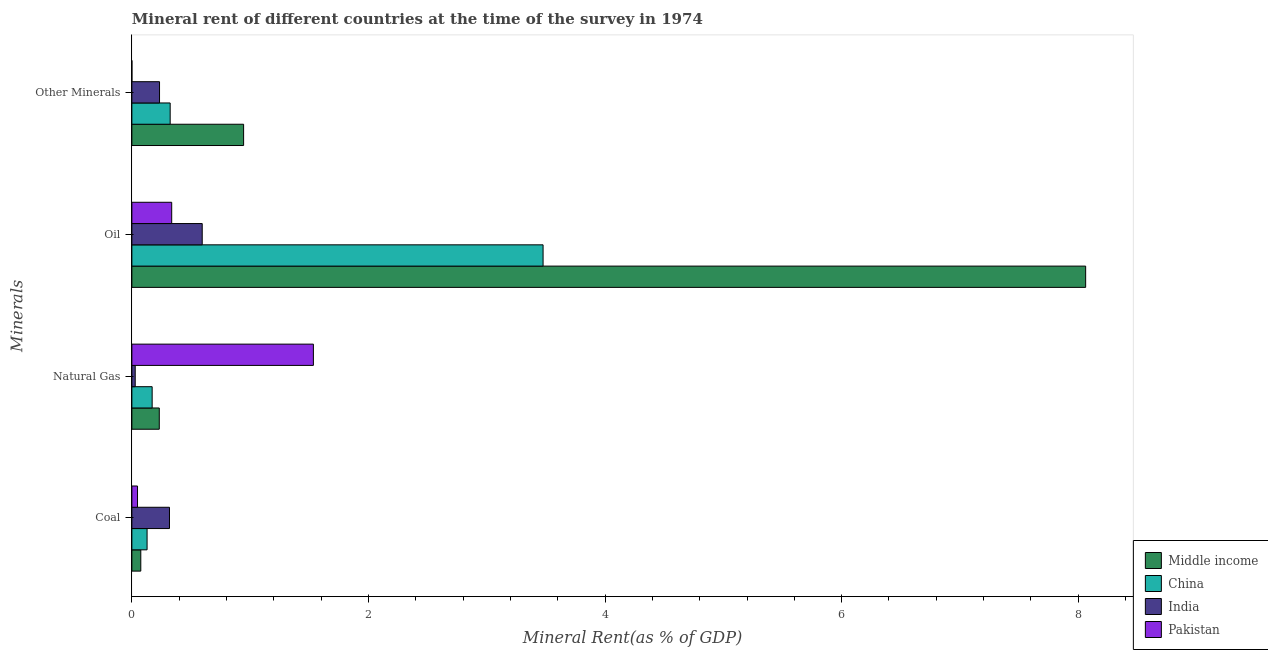How many groups of bars are there?
Your answer should be compact. 4. Are the number of bars per tick equal to the number of legend labels?
Your answer should be compact. Yes. How many bars are there on the 1st tick from the top?
Make the answer very short. 4. What is the label of the 1st group of bars from the top?
Give a very brief answer. Other Minerals. What is the coal rent in China?
Ensure brevity in your answer.  0.13. Across all countries, what is the maximum natural gas rent?
Make the answer very short. 1.53. Across all countries, what is the minimum coal rent?
Your answer should be compact. 0.05. What is the total natural gas rent in the graph?
Provide a short and direct response. 1.97. What is the difference between the oil rent in Pakistan and that in Middle income?
Keep it short and to the point. -7.73. What is the difference between the  rent of other minerals in India and the natural gas rent in China?
Make the answer very short. 0.06. What is the average coal rent per country?
Offer a very short reply. 0.14. What is the difference between the  rent of other minerals and natural gas rent in China?
Your answer should be very brief. 0.15. What is the ratio of the oil rent in Pakistan to that in India?
Offer a very short reply. 0.57. Is the difference between the  rent of other minerals in India and Middle income greater than the difference between the oil rent in India and Middle income?
Give a very brief answer. Yes. What is the difference between the highest and the second highest oil rent?
Offer a very short reply. 4.59. What is the difference between the highest and the lowest oil rent?
Your response must be concise. 7.73. Is it the case that in every country, the sum of the  rent of other minerals and oil rent is greater than the sum of natural gas rent and coal rent?
Your answer should be very brief. No. What does the 4th bar from the top in Oil represents?
Your response must be concise. Middle income. What does the 1st bar from the bottom in Natural Gas represents?
Ensure brevity in your answer.  Middle income. How many bars are there?
Provide a succinct answer. 16. How many countries are there in the graph?
Your answer should be very brief. 4. Does the graph contain grids?
Your answer should be compact. No. How many legend labels are there?
Your answer should be compact. 4. What is the title of the graph?
Keep it short and to the point. Mineral rent of different countries at the time of the survey in 1974. What is the label or title of the X-axis?
Your response must be concise. Mineral Rent(as % of GDP). What is the label or title of the Y-axis?
Provide a succinct answer. Minerals. What is the Mineral Rent(as % of GDP) of Middle income in Coal?
Your answer should be compact. 0.08. What is the Mineral Rent(as % of GDP) in China in Coal?
Keep it short and to the point. 0.13. What is the Mineral Rent(as % of GDP) of India in Coal?
Offer a terse response. 0.32. What is the Mineral Rent(as % of GDP) in Pakistan in Coal?
Ensure brevity in your answer.  0.05. What is the Mineral Rent(as % of GDP) in Middle income in Natural Gas?
Make the answer very short. 0.23. What is the Mineral Rent(as % of GDP) of China in Natural Gas?
Keep it short and to the point. 0.17. What is the Mineral Rent(as % of GDP) in India in Natural Gas?
Offer a terse response. 0.03. What is the Mineral Rent(as % of GDP) in Pakistan in Natural Gas?
Make the answer very short. 1.53. What is the Mineral Rent(as % of GDP) in Middle income in Oil?
Provide a short and direct response. 8.06. What is the Mineral Rent(as % of GDP) in China in Oil?
Make the answer very short. 3.48. What is the Mineral Rent(as % of GDP) in India in Oil?
Your response must be concise. 0.59. What is the Mineral Rent(as % of GDP) of Pakistan in Oil?
Your answer should be compact. 0.34. What is the Mineral Rent(as % of GDP) of Middle income in Other Minerals?
Give a very brief answer. 0.94. What is the Mineral Rent(as % of GDP) in China in Other Minerals?
Your answer should be very brief. 0.32. What is the Mineral Rent(as % of GDP) of India in Other Minerals?
Your answer should be compact. 0.23. What is the Mineral Rent(as % of GDP) in Pakistan in Other Minerals?
Offer a terse response. 8.55208765846003e-5. Across all Minerals, what is the maximum Mineral Rent(as % of GDP) of Middle income?
Your answer should be compact. 8.06. Across all Minerals, what is the maximum Mineral Rent(as % of GDP) of China?
Make the answer very short. 3.48. Across all Minerals, what is the maximum Mineral Rent(as % of GDP) in India?
Keep it short and to the point. 0.59. Across all Minerals, what is the maximum Mineral Rent(as % of GDP) of Pakistan?
Offer a very short reply. 1.53. Across all Minerals, what is the minimum Mineral Rent(as % of GDP) in Middle income?
Your answer should be compact. 0.08. Across all Minerals, what is the minimum Mineral Rent(as % of GDP) in China?
Keep it short and to the point. 0.13. Across all Minerals, what is the minimum Mineral Rent(as % of GDP) in India?
Provide a succinct answer. 0.03. Across all Minerals, what is the minimum Mineral Rent(as % of GDP) in Pakistan?
Your answer should be very brief. 8.55208765846003e-5. What is the total Mineral Rent(as % of GDP) of Middle income in the graph?
Your answer should be compact. 9.31. What is the total Mineral Rent(as % of GDP) in China in the graph?
Keep it short and to the point. 4.1. What is the total Mineral Rent(as % of GDP) in India in the graph?
Offer a terse response. 1.17. What is the total Mineral Rent(as % of GDP) of Pakistan in the graph?
Ensure brevity in your answer.  1.92. What is the difference between the Mineral Rent(as % of GDP) in Middle income in Coal and that in Natural Gas?
Keep it short and to the point. -0.16. What is the difference between the Mineral Rent(as % of GDP) of China in Coal and that in Natural Gas?
Keep it short and to the point. -0.04. What is the difference between the Mineral Rent(as % of GDP) in India in Coal and that in Natural Gas?
Your answer should be compact. 0.29. What is the difference between the Mineral Rent(as % of GDP) in Pakistan in Coal and that in Natural Gas?
Give a very brief answer. -1.49. What is the difference between the Mineral Rent(as % of GDP) of Middle income in Coal and that in Oil?
Offer a very short reply. -7.99. What is the difference between the Mineral Rent(as % of GDP) in China in Coal and that in Oil?
Give a very brief answer. -3.35. What is the difference between the Mineral Rent(as % of GDP) in India in Coal and that in Oil?
Offer a very short reply. -0.28. What is the difference between the Mineral Rent(as % of GDP) in Pakistan in Coal and that in Oil?
Provide a succinct answer. -0.29. What is the difference between the Mineral Rent(as % of GDP) in Middle income in Coal and that in Other Minerals?
Keep it short and to the point. -0.87. What is the difference between the Mineral Rent(as % of GDP) of China in Coal and that in Other Minerals?
Your answer should be compact. -0.2. What is the difference between the Mineral Rent(as % of GDP) of India in Coal and that in Other Minerals?
Keep it short and to the point. 0.08. What is the difference between the Mineral Rent(as % of GDP) in Pakistan in Coal and that in Other Minerals?
Your answer should be very brief. 0.05. What is the difference between the Mineral Rent(as % of GDP) of Middle income in Natural Gas and that in Oil?
Provide a succinct answer. -7.83. What is the difference between the Mineral Rent(as % of GDP) in China in Natural Gas and that in Oil?
Offer a very short reply. -3.3. What is the difference between the Mineral Rent(as % of GDP) in India in Natural Gas and that in Oil?
Offer a very short reply. -0.57. What is the difference between the Mineral Rent(as % of GDP) in Pakistan in Natural Gas and that in Oil?
Ensure brevity in your answer.  1.2. What is the difference between the Mineral Rent(as % of GDP) in Middle income in Natural Gas and that in Other Minerals?
Provide a succinct answer. -0.71. What is the difference between the Mineral Rent(as % of GDP) in China in Natural Gas and that in Other Minerals?
Make the answer very short. -0.15. What is the difference between the Mineral Rent(as % of GDP) in India in Natural Gas and that in Other Minerals?
Offer a very short reply. -0.21. What is the difference between the Mineral Rent(as % of GDP) of Pakistan in Natural Gas and that in Other Minerals?
Keep it short and to the point. 1.53. What is the difference between the Mineral Rent(as % of GDP) in Middle income in Oil and that in Other Minerals?
Your answer should be very brief. 7.12. What is the difference between the Mineral Rent(as % of GDP) of China in Oil and that in Other Minerals?
Offer a terse response. 3.15. What is the difference between the Mineral Rent(as % of GDP) in India in Oil and that in Other Minerals?
Keep it short and to the point. 0.36. What is the difference between the Mineral Rent(as % of GDP) of Pakistan in Oil and that in Other Minerals?
Provide a short and direct response. 0.34. What is the difference between the Mineral Rent(as % of GDP) of Middle income in Coal and the Mineral Rent(as % of GDP) of China in Natural Gas?
Your answer should be very brief. -0.1. What is the difference between the Mineral Rent(as % of GDP) of Middle income in Coal and the Mineral Rent(as % of GDP) of India in Natural Gas?
Give a very brief answer. 0.05. What is the difference between the Mineral Rent(as % of GDP) in Middle income in Coal and the Mineral Rent(as % of GDP) in Pakistan in Natural Gas?
Your answer should be very brief. -1.46. What is the difference between the Mineral Rent(as % of GDP) in China in Coal and the Mineral Rent(as % of GDP) in India in Natural Gas?
Provide a short and direct response. 0.1. What is the difference between the Mineral Rent(as % of GDP) of China in Coal and the Mineral Rent(as % of GDP) of Pakistan in Natural Gas?
Ensure brevity in your answer.  -1.41. What is the difference between the Mineral Rent(as % of GDP) of India in Coal and the Mineral Rent(as % of GDP) of Pakistan in Natural Gas?
Your response must be concise. -1.22. What is the difference between the Mineral Rent(as % of GDP) of Middle income in Coal and the Mineral Rent(as % of GDP) of China in Oil?
Offer a very short reply. -3.4. What is the difference between the Mineral Rent(as % of GDP) of Middle income in Coal and the Mineral Rent(as % of GDP) of India in Oil?
Make the answer very short. -0.52. What is the difference between the Mineral Rent(as % of GDP) in Middle income in Coal and the Mineral Rent(as % of GDP) in Pakistan in Oil?
Offer a terse response. -0.26. What is the difference between the Mineral Rent(as % of GDP) of China in Coal and the Mineral Rent(as % of GDP) of India in Oil?
Provide a succinct answer. -0.47. What is the difference between the Mineral Rent(as % of GDP) in China in Coal and the Mineral Rent(as % of GDP) in Pakistan in Oil?
Provide a succinct answer. -0.21. What is the difference between the Mineral Rent(as % of GDP) of India in Coal and the Mineral Rent(as % of GDP) of Pakistan in Oil?
Keep it short and to the point. -0.02. What is the difference between the Mineral Rent(as % of GDP) in Middle income in Coal and the Mineral Rent(as % of GDP) in China in Other Minerals?
Keep it short and to the point. -0.25. What is the difference between the Mineral Rent(as % of GDP) of Middle income in Coal and the Mineral Rent(as % of GDP) of India in Other Minerals?
Keep it short and to the point. -0.16. What is the difference between the Mineral Rent(as % of GDP) in Middle income in Coal and the Mineral Rent(as % of GDP) in Pakistan in Other Minerals?
Your answer should be very brief. 0.08. What is the difference between the Mineral Rent(as % of GDP) in China in Coal and the Mineral Rent(as % of GDP) in India in Other Minerals?
Ensure brevity in your answer.  -0.11. What is the difference between the Mineral Rent(as % of GDP) in China in Coal and the Mineral Rent(as % of GDP) in Pakistan in Other Minerals?
Offer a terse response. 0.13. What is the difference between the Mineral Rent(as % of GDP) of India in Coal and the Mineral Rent(as % of GDP) of Pakistan in Other Minerals?
Provide a succinct answer. 0.32. What is the difference between the Mineral Rent(as % of GDP) in Middle income in Natural Gas and the Mineral Rent(as % of GDP) in China in Oil?
Provide a succinct answer. -3.24. What is the difference between the Mineral Rent(as % of GDP) in Middle income in Natural Gas and the Mineral Rent(as % of GDP) in India in Oil?
Make the answer very short. -0.36. What is the difference between the Mineral Rent(as % of GDP) of Middle income in Natural Gas and the Mineral Rent(as % of GDP) of Pakistan in Oil?
Make the answer very short. -0.1. What is the difference between the Mineral Rent(as % of GDP) in China in Natural Gas and the Mineral Rent(as % of GDP) in India in Oil?
Your response must be concise. -0.42. What is the difference between the Mineral Rent(as % of GDP) of China in Natural Gas and the Mineral Rent(as % of GDP) of Pakistan in Oil?
Your response must be concise. -0.17. What is the difference between the Mineral Rent(as % of GDP) of India in Natural Gas and the Mineral Rent(as % of GDP) of Pakistan in Oil?
Ensure brevity in your answer.  -0.31. What is the difference between the Mineral Rent(as % of GDP) of Middle income in Natural Gas and the Mineral Rent(as % of GDP) of China in Other Minerals?
Make the answer very short. -0.09. What is the difference between the Mineral Rent(as % of GDP) of Middle income in Natural Gas and the Mineral Rent(as % of GDP) of India in Other Minerals?
Give a very brief answer. -0. What is the difference between the Mineral Rent(as % of GDP) in Middle income in Natural Gas and the Mineral Rent(as % of GDP) in Pakistan in Other Minerals?
Provide a short and direct response. 0.23. What is the difference between the Mineral Rent(as % of GDP) of China in Natural Gas and the Mineral Rent(as % of GDP) of India in Other Minerals?
Make the answer very short. -0.06. What is the difference between the Mineral Rent(as % of GDP) of China in Natural Gas and the Mineral Rent(as % of GDP) of Pakistan in Other Minerals?
Keep it short and to the point. 0.17. What is the difference between the Mineral Rent(as % of GDP) in India in Natural Gas and the Mineral Rent(as % of GDP) in Pakistan in Other Minerals?
Offer a very short reply. 0.03. What is the difference between the Mineral Rent(as % of GDP) in Middle income in Oil and the Mineral Rent(as % of GDP) in China in Other Minerals?
Make the answer very short. 7.74. What is the difference between the Mineral Rent(as % of GDP) of Middle income in Oil and the Mineral Rent(as % of GDP) of India in Other Minerals?
Your response must be concise. 7.83. What is the difference between the Mineral Rent(as % of GDP) of Middle income in Oil and the Mineral Rent(as % of GDP) of Pakistan in Other Minerals?
Your answer should be very brief. 8.06. What is the difference between the Mineral Rent(as % of GDP) in China in Oil and the Mineral Rent(as % of GDP) in India in Other Minerals?
Make the answer very short. 3.24. What is the difference between the Mineral Rent(as % of GDP) in China in Oil and the Mineral Rent(as % of GDP) in Pakistan in Other Minerals?
Give a very brief answer. 3.48. What is the difference between the Mineral Rent(as % of GDP) in India in Oil and the Mineral Rent(as % of GDP) in Pakistan in Other Minerals?
Keep it short and to the point. 0.59. What is the average Mineral Rent(as % of GDP) in Middle income per Minerals?
Provide a succinct answer. 2.33. What is the average Mineral Rent(as % of GDP) in China per Minerals?
Provide a short and direct response. 1.02. What is the average Mineral Rent(as % of GDP) in India per Minerals?
Offer a very short reply. 0.29. What is the average Mineral Rent(as % of GDP) of Pakistan per Minerals?
Offer a very short reply. 0.48. What is the difference between the Mineral Rent(as % of GDP) of Middle income and Mineral Rent(as % of GDP) of China in Coal?
Keep it short and to the point. -0.05. What is the difference between the Mineral Rent(as % of GDP) in Middle income and Mineral Rent(as % of GDP) in India in Coal?
Ensure brevity in your answer.  -0.24. What is the difference between the Mineral Rent(as % of GDP) of Middle income and Mineral Rent(as % of GDP) of Pakistan in Coal?
Ensure brevity in your answer.  0.03. What is the difference between the Mineral Rent(as % of GDP) of China and Mineral Rent(as % of GDP) of India in Coal?
Provide a succinct answer. -0.19. What is the difference between the Mineral Rent(as % of GDP) in China and Mineral Rent(as % of GDP) in Pakistan in Coal?
Make the answer very short. 0.08. What is the difference between the Mineral Rent(as % of GDP) of India and Mineral Rent(as % of GDP) of Pakistan in Coal?
Your answer should be very brief. 0.27. What is the difference between the Mineral Rent(as % of GDP) in Middle income and Mineral Rent(as % of GDP) in China in Natural Gas?
Provide a short and direct response. 0.06. What is the difference between the Mineral Rent(as % of GDP) of Middle income and Mineral Rent(as % of GDP) of India in Natural Gas?
Offer a very short reply. 0.2. What is the difference between the Mineral Rent(as % of GDP) of Middle income and Mineral Rent(as % of GDP) of Pakistan in Natural Gas?
Offer a very short reply. -1.3. What is the difference between the Mineral Rent(as % of GDP) of China and Mineral Rent(as % of GDP) of India in Natural Gas?
Keep it short and to the point. 0.14. What is the difference between the Mineral Rent(as % of GDP) of China and Mineral Rent(as % of GDP) of Pakistan in Natural Gas?
Your answer should be very brief. -1.36. What is the difference between the Mineral Rent(as % of GDP) in India and Mineral Rent(as % of GDP) in Pakistan in Natural Gas?
Offer a very short reply. -1.51. What is the difference between the Mineral Rent(as % of GDP) of Middle income and Mineral Rent(as % of GDP) of China in Oil?
Your answer should be very brief. 4.59. What is the difference between the Mineral Rent(as % of GDP) of Middle income and Mineral Rent(as % of GDP) of India in Oil?
Offer a very short reply. 7.47. What is the difference between the Mineral Rent(as % of GDP) of Middle income and Mineral Rent(as % of GDP) of Pakistan in Oil?
Offer a very short reply. 7.73. What is the difference between the Mineral Rent(as % of GDP) of China and Mineral Rent(as % of GDP) of India in Oil?
Provide a succinct answer. 2.88. What is the difference between the Mineral Rent(as % of GDP) of China and Mineral Rent(as % of GDP) of Pakistan in Oil?
Give a very brief answer. 3.14. What is the difference between the Mineral Rent(as % of GDP) of India and Mineral Rent(as % of GDP) of Pakistan in Oil?
Give a very brief answer. 0.26. What is the difference between the Mineral Rent(as % of GDP) in Middle income and Mineral Rent(as % of GDP) in China in Other Minerals?
Your answer should be compact. 0.62. What is the difference between the Mineral Rent(as % of GDP) in Middle income and Mineral Rent(as % of GDP) in India in Other Minerals?
Make the answer very short. 0.71. What is the difference between the Mineral Rent(as % of GDP) of Middle income and Mineral Rent(as % of GDP) of Pakistan in Other Minerals?
Your answer should be compact. 0.94. What is the difference between the Mineral Rent(as % of GDP) in China and Mineral Rent(as % of GDP) in India in Other Minerals?
Your response must be concise. 0.09. What is the difference between the Mineral Rent(as % of GDP) in China and Mineral Rent(as % of GDP) in Pakistan in Other Minerals?
Your answer should be very brief. 0.32. What is the difference between the Mineral Rent(as % of GDP) of India and Mineral Rent(as % of GDP) of Pakistan in Other Minerals?
Ensure brevity in your answer.  0.23. What is the ratio of the Mineral Rent(as % of GDP) in Middle income in Coal to that in Natural Gas?
Provide a short and direct response. 0.33. What is the ratio of the Mineral Rent(as % of GDP) in China in Coal to that in Natural Gas?
Offer a very short reply. 0.75. What is the ratio of the Mineral Rent(as % of GDP) of India in Coal to that in Natural Gas?
Offer a terse response. 11.25. What is the ratio of the Mineral Rent(as % of GDP) of Pakistan in Coal to that in Natural Gas?
Your answer should be compact. 0.03. What is the ratio of the Mineral Rent(as % of GDP) of Middle income in Coal to that in Oil?
Offer a very short reply. 0.01. What is the ratio of the Mineral Rent(as % of GDP) in China in Coal to that in Oil?
Keep it short and to the point. 0.04. What is the ratio of the Mineral Rent(as % of GDP) in India in Coal to that in Oil?
Your response must be concise. 0.53. What is the ratio of the Mineral Rent(as % of GDP) in Pakistan in Coal to that in Oil?
Keep it short and to the point. 0.14. What is the ratio of the Mineral Rent(as % of GDP) in Middle income in Coal to that in Other Minerals?
Your response must be concise. 0.08. What is the ratio of the Mineral Rent(as % of GDP) in China in Coal to that in Other Minerals?
Make the answer very short. 0.4. What is the ratio of the Mineral Rent(as % of GDP) in India in Coal to that in Other Minerals?
Make the answer very short. 1.36. What is the ratio of the Mineral Rent(as % of GDP) of Pakistan in Coal to that in Other Minerals?
Your answer should be compact. 557.6. What is the ratio of the Mineral Rent(as % of GDP) in Middle income in Natural Gas to that in Oil?
Your answer should be compact. 0.03. What is the ratio of the Mineral Rent(as % of GDP) of China in Natural Gas to that in Oil?
Ensure brevity in your answer.  0.05. What is the ratio of the Mineral Rent(as % of GDP) in India in Natural Gas to that in Oil?
Provide a succinct answer. 0.05. What is the ratio of the Mineral Rent(as % of GDP) in Pakistan in Natural Gas to that in Oil?
Ensure brevity in your answer.  4.56. What is the ratio of the Mineral Rent(as % of GDP) of Middle income in Natural Gas to that in Other Minerals?
Your answer should be compact. 0.25. What is the ratio of the Mineral Rent(as % of GDP) of China in Natural Gas to that in Other Minerals?
Your response must be concise. 0.53. What is the ratio of the Mineral Rent(as % of GDP) in India in Natural Gas to that in Other Minerals?
Provide a succinct answer. 0.12. What is the ratio of the Mineral Rent(as % of GDP) of Pakistan in Natural Gas to that in Other Minerals?
Keep it short and to the point. 1.79e+04. What is the ratio of the Mineral Rent(as % of GDP) of Middle income in Oil to that in Other Minerals?
Provide a short and direct response. 8.54. What is the ratio of the Mineral Rent(as % of GDP) in China in Oil to that in Other Minerals?
Give a very brief answer. 10.74. What is the ratio of the Mineral Rent(as % of GDP) in India in Oil to that in Other Minerals?
Your answer should be compact. 2.54. What is the ratio of the Mineral Rent(as % of GDP) in Pakistan in Oil to that in Other Minerals?
Keep it short and to the point. 3936.31. What is the difference between the highest and the second highest Mineral Rent(as % of GDP) of Middle income?
Offer a very short reply. 7.12. What is the difference between the highest and the second highest Mineral Rent(as % of GDP) of China?
Make the answer very short. 3.15. What is the difference between the highest and the second highest Mineral Rent(as % of GDP) in India?
Give a very brief answer. 0.28. What is the difference between the highest and the second highest Mineral Rent(as % of GDP) in Pakistan?
Offer a terse response. 1.2. What is the difference between the highest and the lowest Mineral Rent(as % of GDP) in Middle income?
Offer a terse response. 7.99. What is the difference between the highest and the lowest Mineral Rent(as % of GDP) in China?
Your answer should be very brief. 3.35. What is the difference between the highest and the lowest Mineral Rent(as % of GDP) of India?
Your answer should be compact. 0.57. What is the difference between the highest and the lowest Mineral Rent(as % of GDP) in Pakistan?
Your answer should be compact. 1.53. 